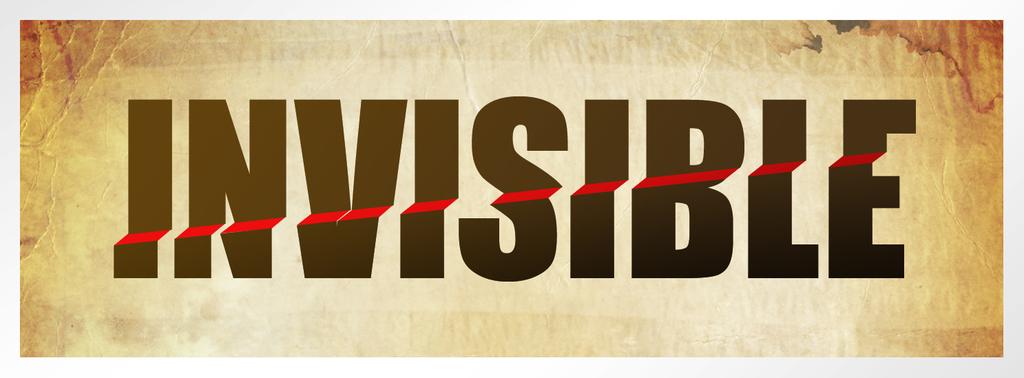What is the word with a red line running through it?
Ensure brevity in your answer.  Invisible. 